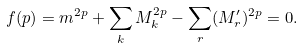Convert formula to latex. <formula><loc_0><loc_0><loc_500><loc_500>f ( p ) = m ^ { 2 p } + \sum _ { k } M _ { k } ^ { 2 p } - \sum _ { r } ( M ^ { \prime } _ { r } ) ^ { 2 p } = 0 .</formula> 